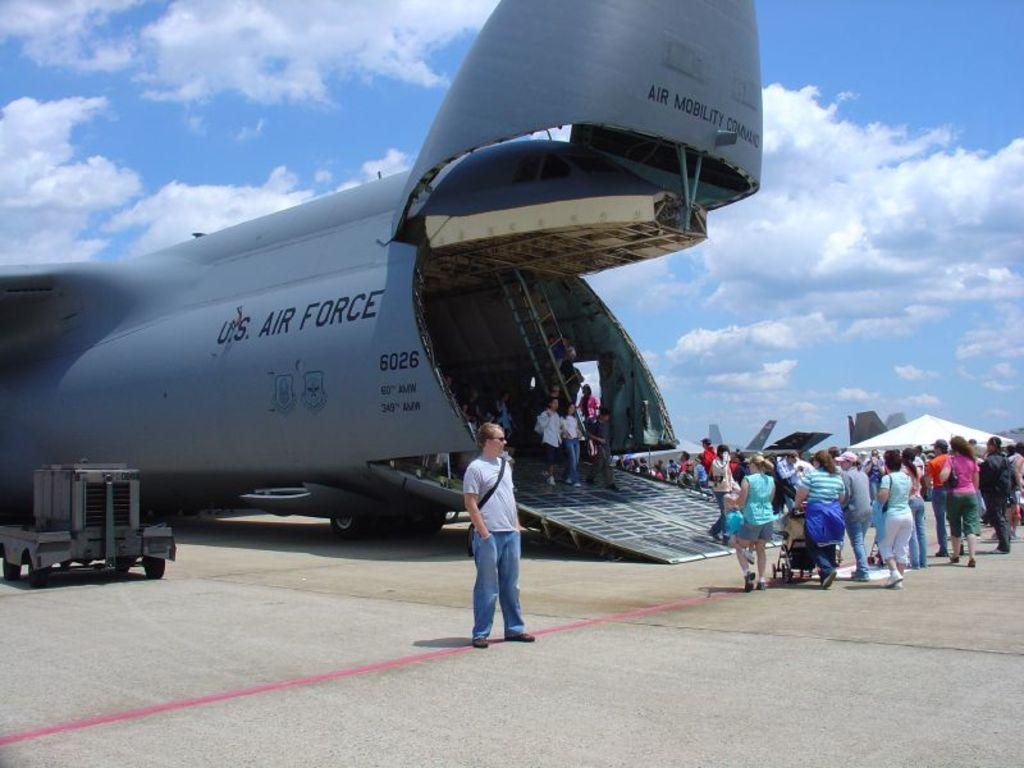<image>
Relay a brief, clear account of the picture shown. A crowd is gathered around an Air Force plane. 